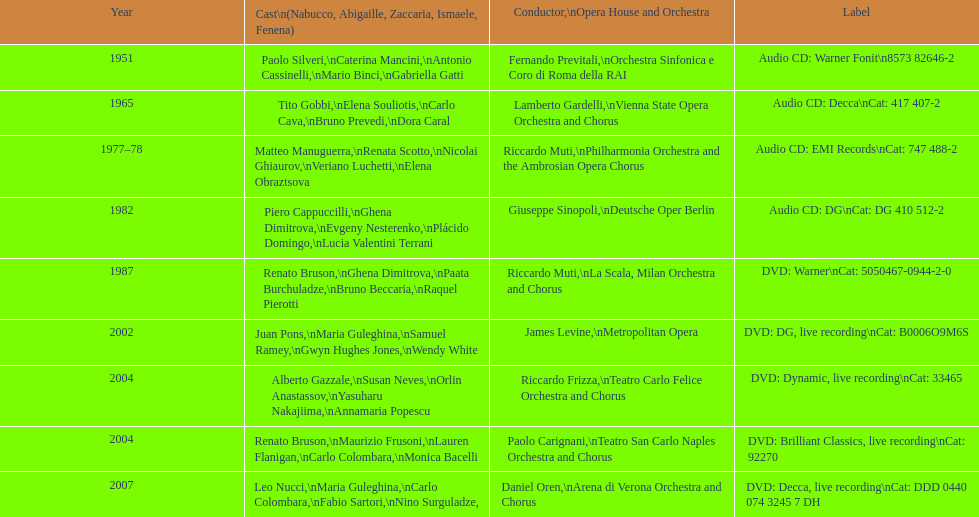When was the recording of nabucco made in the metropolitan opera? 2002. 